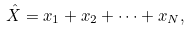Convert formula to latex. <formula><loc_0><loc_0><loc_500><loc_500>\hat { X } = x _ { 1 } + x _ { 2 } + \dots + x _ { N } ,</formula> 